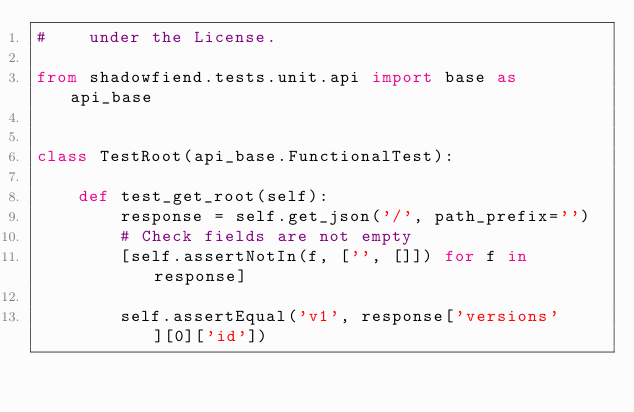Convert code to text. <code><loc_0><loc_0><loc_500><loc_500><_Python_>#    under the License.

from shadowfiend.tests.unit.api import base as api_base


class TestRoot(api_base.FunctionalTest):

    def test_get_root(self):
        response = self.get_json('/', path_prefix='')
        # Check fields are not empty
        [self.assertNotIn(f, ['', []]) for f in response]

        self.assertEqual('v1', response['versions'][0]['id'])
</code> 